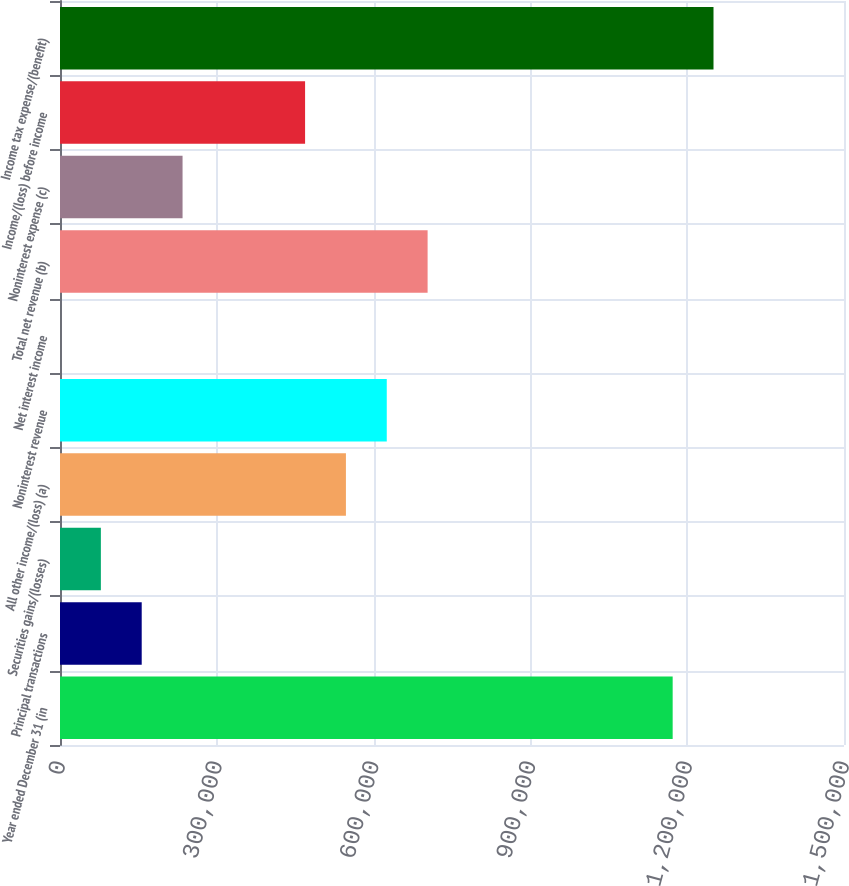Convert chart to OTSL. <chart><loc_0><loc_0><loc_500><loc_500><bar_chart><fcel>Year ended December 31 (in<fcel>Principal transactions<fcel>Securities gains/(losses)<fcel>All other income/(loss) (a)<fcel>Noninterest revenue<fcel>Net interest income<fcel>Total net revenue (b)<fcel>Noninterest expense (c)<fcel>Income/(loss) before income<fcel>Income tax expense/(benefit)<nl><fcel>1.17219e+06<fcel>156340<fcel>78197.3<fcel>547051<fcel>625193<fcel>55<fcel>703336<fcel>234482<fcel>468909<fcel>1.25033e+06<nl></chart> 